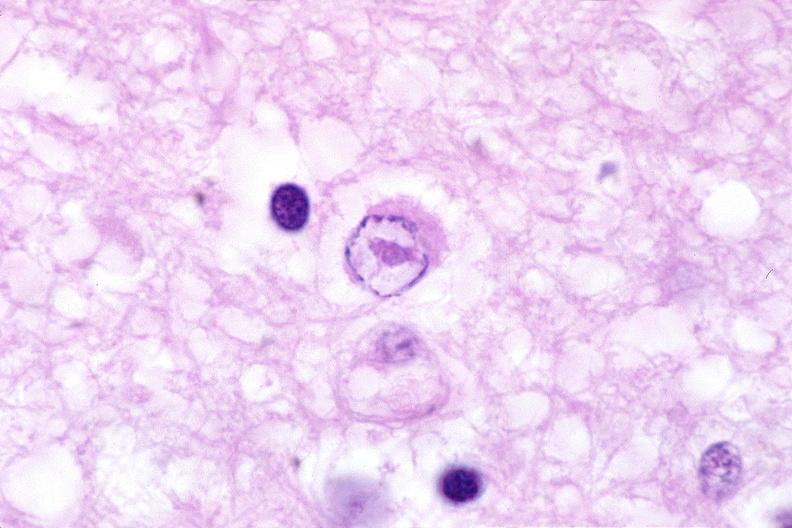how does this image show brain, herpes encephalitis?
Answer the question using a single word or phrase. With inclusion bodies 